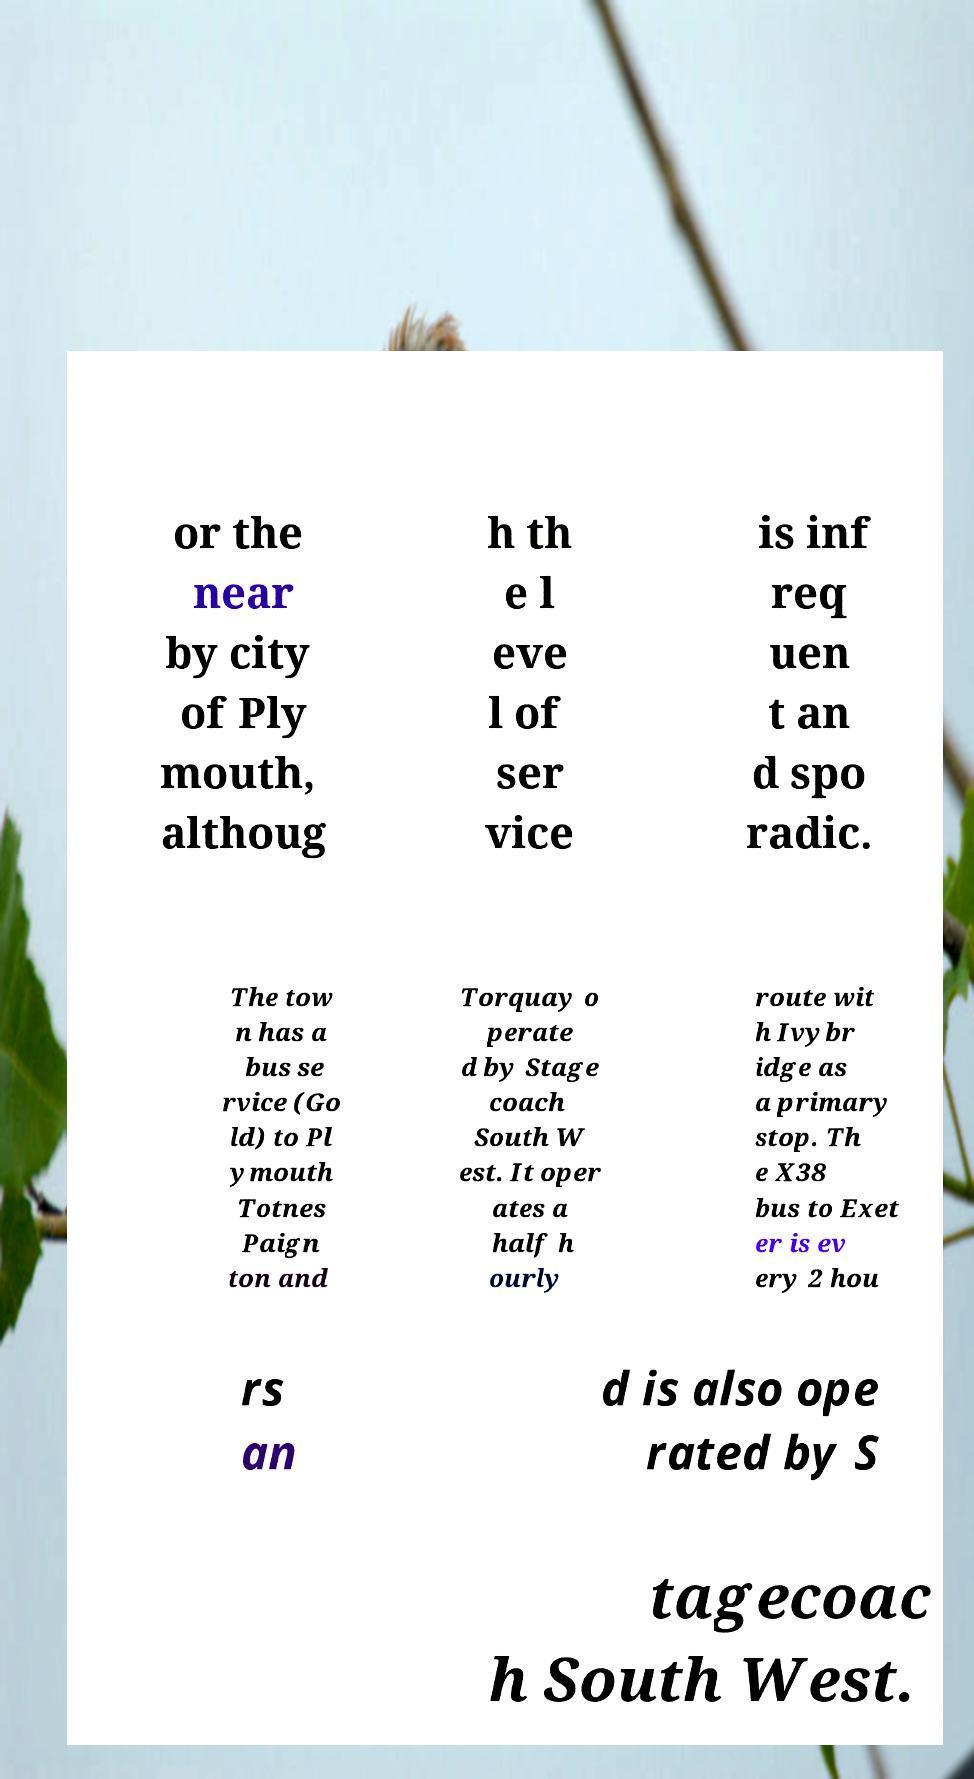Could you extract and type out the text from this image? or the near by city of Ply mouth, althoug h th e l eve l of ser vice is inf req uen t an d spo radic. The tow n has a bus se rvice (Go ld) to Pl ymouth Totnes Paign ton and Torquay o perate d by Stage coach South W est. It oper ates a half h ourly route wit h Ivybr idge as a primary stop. Th e X38 bus to Exet er is ev ery 2 hou rs an d is also ope rated by S tagecoac h South West. 